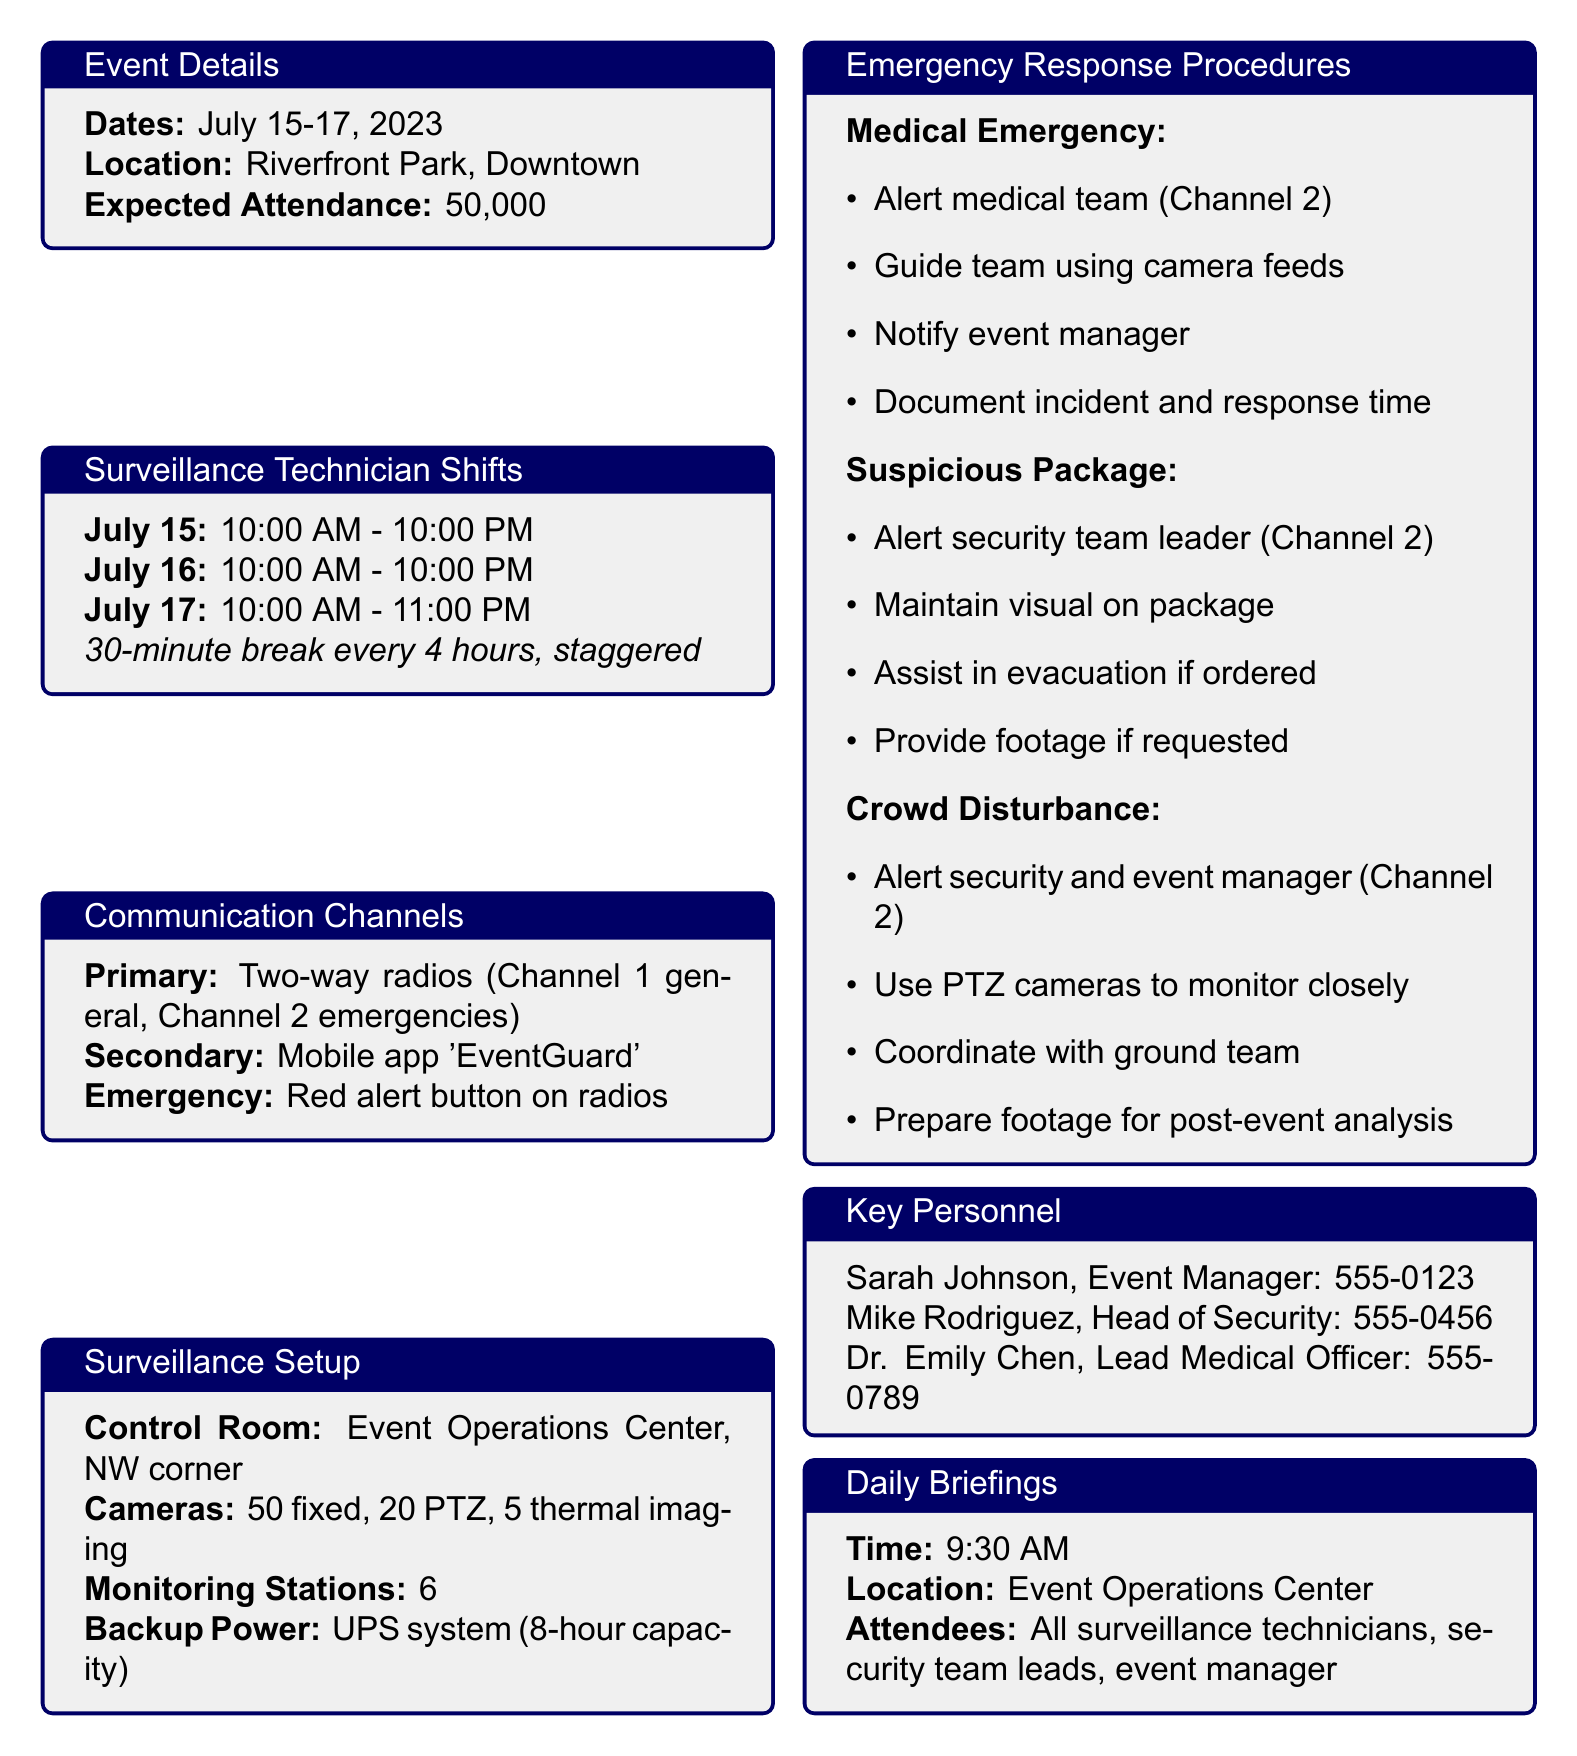What are the dates of the festival? The dates of the festival are listed in the document under event details.
Answer: July 15-17, 2023 What is the expected attendance? The expected attendance is mentioned in the event details.
Answer: 50,000 What time does the Surveillance Technician begin their shift on July 15? The start time for the Surveillance Technician's shift is provided in the staff shifts section.
Answer: 10:00 AM How many monitoring stations are there in the control room? The number of monitoring stations is stated in the surveillance setup section.
Answer: 6 What emergency procedure involves notifying the event manager? The scenario that requires notifying the event manager is detailed in the emergency response procedures section.
Answer: Crowd Disturbance Who is the Lead Medical Officer? The key personnel section provides the names and roles of individuals at the event.
Answer: Dr. Emily Chen What is the primary communication channel for emergencies? The primary emergency communication method is specified in the communication channels section.
Answer: Two-way radios (Channel 2 for emergencies) At what time are the daily briefings scheduled? The time for daily briefings is outlined in the daily briefings section of the document.
Answer: 9:30 AM What is the deadline for post-event reporting? The deadline for post-event reporting is clearly mentioned in that section of the memo.
Answer: Within 48 hours of event conclusion 